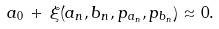Convert formula to latex. <formula><loc_0><loc_0><loc_500><loc_500>a _ { 0 } \, + \, \xi ( a _ { n } , b _ { n } , p _ { a _ { n } } , p _ { b _ { n } } ) \approx 0 .</formula> 